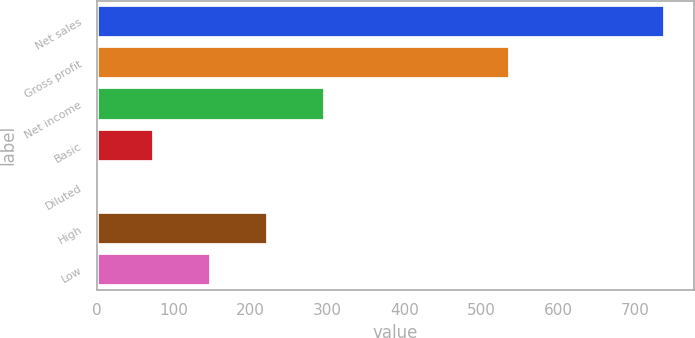Convert chart. <chart><loc_0><loc_0><loc_500><loc_500><bar_chart><fcel>Net sales<fcel>Gross profit<fcel>Net income<fcel>Basic<fcel>Diluted<fcel>High<fcel>Low<nl><fcel>739.4<fcel>538<fcel>296.15<fcel>74.53<fcel>0.65<fcel>222.28<fcel>148.41<nl></chart> 